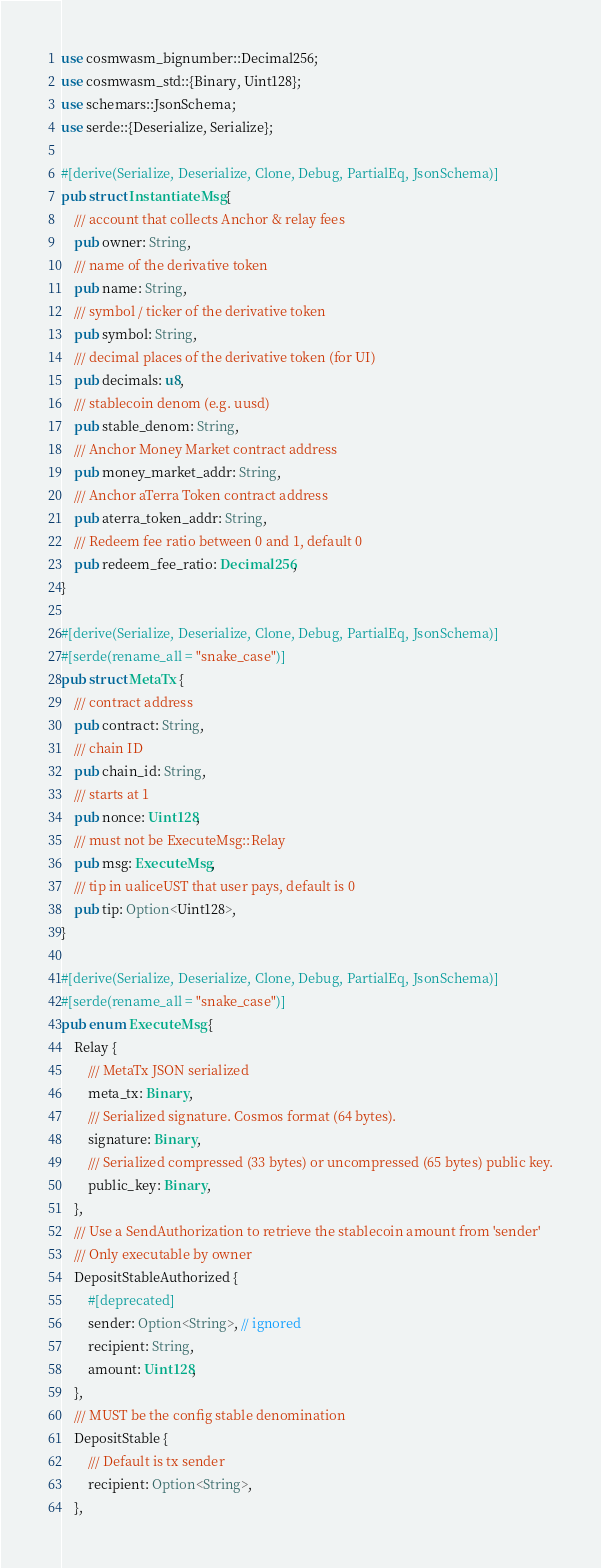Convert code to text. <code><loc_0><loc_0><loc_500><loc_500><_Rust_>use cosmwasm_bignumber::Decimal256;
use cosmwasm_std::{Binary, Uint128};
use schemars::JsonSchema;
use serde::{Deserialize, Serialize};

#[derive(Serialize, Deserialize, Clone, Debug, PartialEq, JsonSchema)]
pub struct InstantiateMsg {
    /// account that collects Anchor & relay fees
    pub owner: String,
    /// name of the derivative token
    pub name: String,
    /// symbol / ticker of the derivative token
    pub symbol: String,
    /// decimal places of the derivative token (for UI)
    pub decimals: u8,
    /// stablecoin denom (e.g. uusd)
    pub stable_denom: String,
    /// Anchor Money Market contract address
    pub money_market_addr: String,
    /// Anchor aTerra Token contract address
    pub aterra_token_addr: String,
    /// Redeem fee ratio between 0 and 1, default 0
    pub redeem_fee_ratio: Decimal256,
}

#[derive(Serialize, Deserialize, Clone, Debug, PartialEq, JsonSchema)]
#[serde(rename_all = "snake_case")]
pub struct MetaTx {
    /// contract address
    pub contract: String,
    /// chain ID
    pub chain_id: String,
    /// starts at 1
    pub nonce: Uint128,
    /// must not be ExecuteMsg::Relay
    pub msg: ExecuteMsg,
    /// tip in ualiceUST that user pays, default is 0
    pub tip: Option<Uint128>,
}

#[derive(Serialize, Deserialize, Clone, Debug, PartialEq, JsonSchema)]
#[serde(rename_all = "snake_case")]
pub enum ExecuteMsg {
    Relay {
        /// MetaTx JSON serialized
        meta_tx: Binary,
        /// Serialized signature. Cosmos format (64 bytes).
        signature: Binary,
        /// Serialized compressed (33 bytes) or uncompressed (65 bytes) public key.
        public_key: Binary,
    },
    /// Use a SendAuthorization to retrieve the stablecoin amount from 'sender'
    /// Only executable by owner
    DepositStableAuthorized {
        #[deprecated]
        sender: Option<String>, // ignored
        recipient: String,
        amount: Uint128,
    },
    /// MUST be the config stable denomination
    DepositStable {
        /// Default is tx sender
        recipient: Option<String>,
    },</code> 